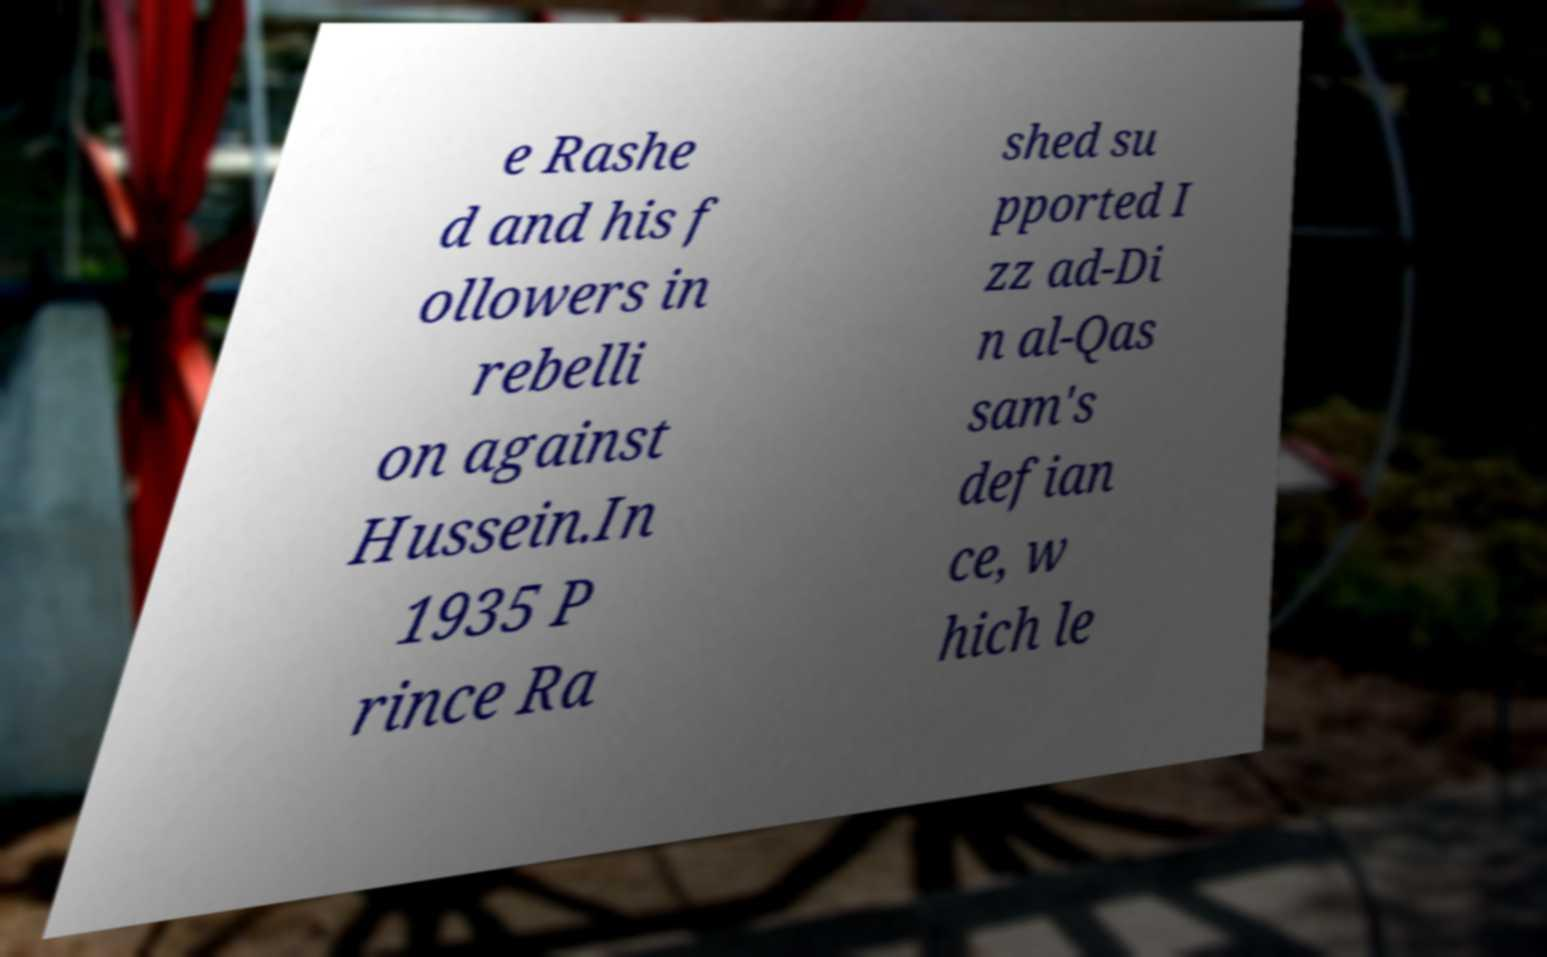Could you assist in decoding the text presented in this image and type it out clearly? e Rashe d and his f ollowers in rebelli on against Hussein.In 1935 P rince Ra shed su pported I zz ad-Di n al-Qas sam's defian ce, w hich le 